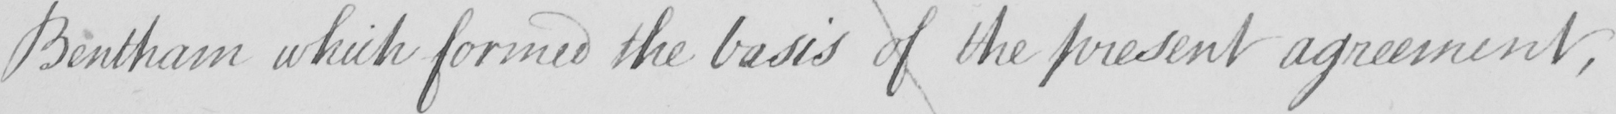Please provide the text content of this handwritten line. Bentham which formed the basis of the present agreement , 